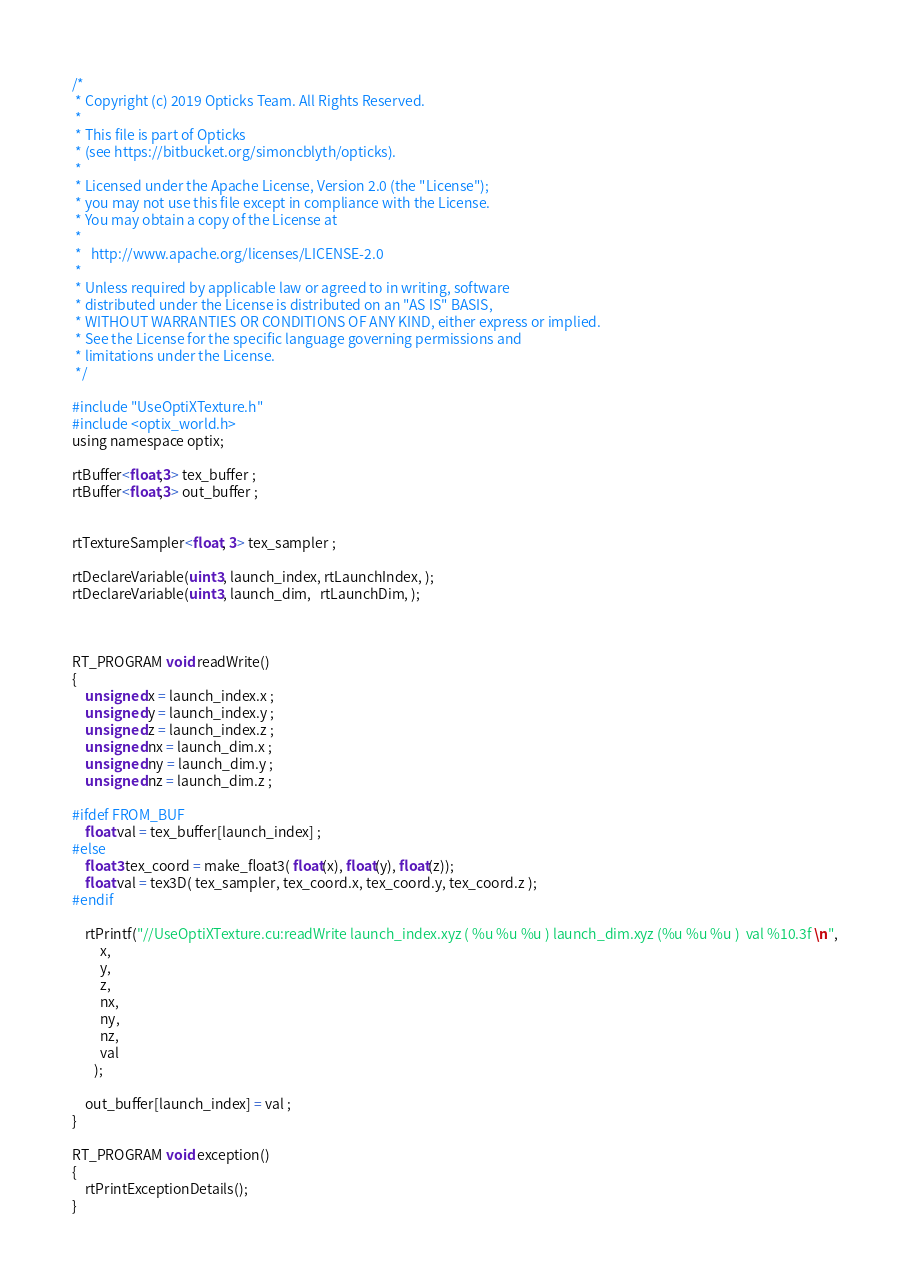Convert code to text. <code><loc_0><loc_0><loc_500><loc_500><_Cuda_>/*
 * Copyright (c) 2019 Opticks Team. All Rights Reserved.
 *
 * This file is part of Opticks
 * (see https://bitbucket.org/simoncblyth/opticks).
 *
 * Licensed under the Apache License, Version 2.0 (the "License"); 
 * you may not use this file except in compliance with the License.  
 * You may obtain a copy of the License at
 *
 *   http://www.apache.org/licenses/LICENSE-2.0
 *
 * Unless required by applicable law or agreed to in writing, software 
 * distributed under the License is distributed on an "AS IS" BASIS, 
 * WITHOUT WARRANTIES OR CONDITIONS OF ANY KIND, either express or implied.  
 * See the License for the specific language governing permissions and 
 * limitations under the License.
 */

#include "UseOptiXTexture.h"
#include <optix_world.h>
using namespace optix;

rtBuffer<float,3> tex_buffer ; 
rtBuffer<float,3> out_buffer ; 


rtTextureSampler<float, 3> tex_sampler ;

rtDeclareVariable(uint3, launch_index, rtLaunchIndex, );
rtDeclareVariable(uint3, launch_dim,   rtLaunchDim, );



RT_PROGRAM void readWrite()
{
    unsigned x = launch_index.x ; 
    unsigned y = launch_index.y ; 
    unsigned z = launch_index.z ; 
    unsigned nx = launch_dim.x ; 
    unsigned ny = launch_dim.y ; 
    unsigned nz = launch_dim.z ; 

#ifdef FROM_BUF
    float val = tex_buffer[launch_index] ;  
#else
    float3 tex_coord = make_float3( float(x), float(y), float(z)); 
    float val = tex3D( tex_sampler, tex_coord.x, tex_coord.y, tex_coord.z );
#endif

    rtPrintf("//UseOptiXTexture.cu:readWrite launch_index.xyz ( %u %u %u ) launch_dim.xyz (%u %u %u )  val %10.3f \n", 
         x, 
         y, 
         z, 
         nx, 
         ny, 
         nz, 
         val
       );

    out_buffer[launch_index] = val ; 
}

RT_PROGRAM void exception()
{
    rtPrintExceptionDetails();
}


</code> 